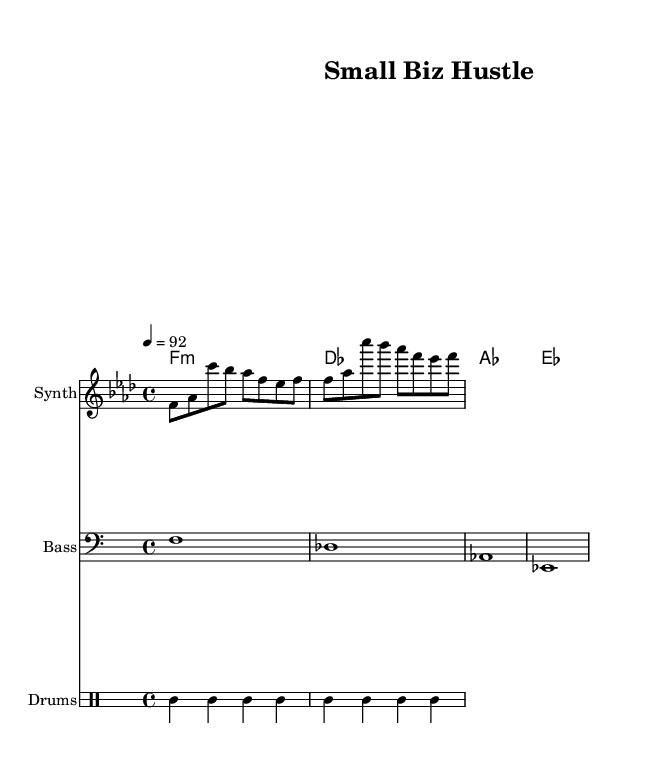What is the key signature of this music? The key signature indicated in the music is F minor, which has four flats (B, E, A, D).
Answer: F minor What is the time signature of this music? The time signature shown in the music is 4/4, which means there are four beats in each measure.
Answer: 4/4 What is the tempo marking of the piece? The tempo marking is 92 beats per minute, which indicates the speed of the music.
Answer: 92 How many measures does the melody section contain? The melody section consists of two identical measures repeated, totaling two measures.
Answer: 2 What are the first two chords listed in the harmonies? The first two chords in the harmonies are F minor and D flat major.
Answer: F minor, D flat major How does the drum pattern start? The drum pattern starts with a bass drum followed by a hi-hat and then a snare drum.
Answer: Bass drum What unique element does the hip hop genre add to this piece? The piece incorporates a drum set, which is essential for creating the hip hop rhythm and beat.
Answer: Drum set 